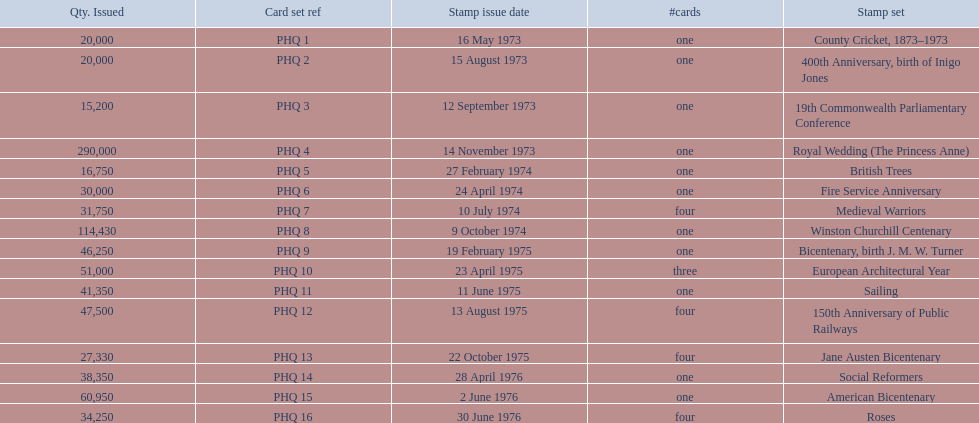Which stamp sets were issued? County Cricket, 1873–1973, 400th Anniversary, birth of Inigo Jones, 19th Commonwealth Parliamentary Conference, Royal Wedding (The Princess Anne), British Trees, Fire Service Anniversary, Medieval Warriors, Winston Churchill Centenary, Bicentenary, birth J. M. W. Turner, European Architectural Year, Sailing, 150th Anniversary of Public Railways, Jane Austen Bicentenary, Social Reformers, American Bicentenary, Roses. Of those stamp sets, which had more that 200,000 issued? Royal Wedding (The Princess Anne). 